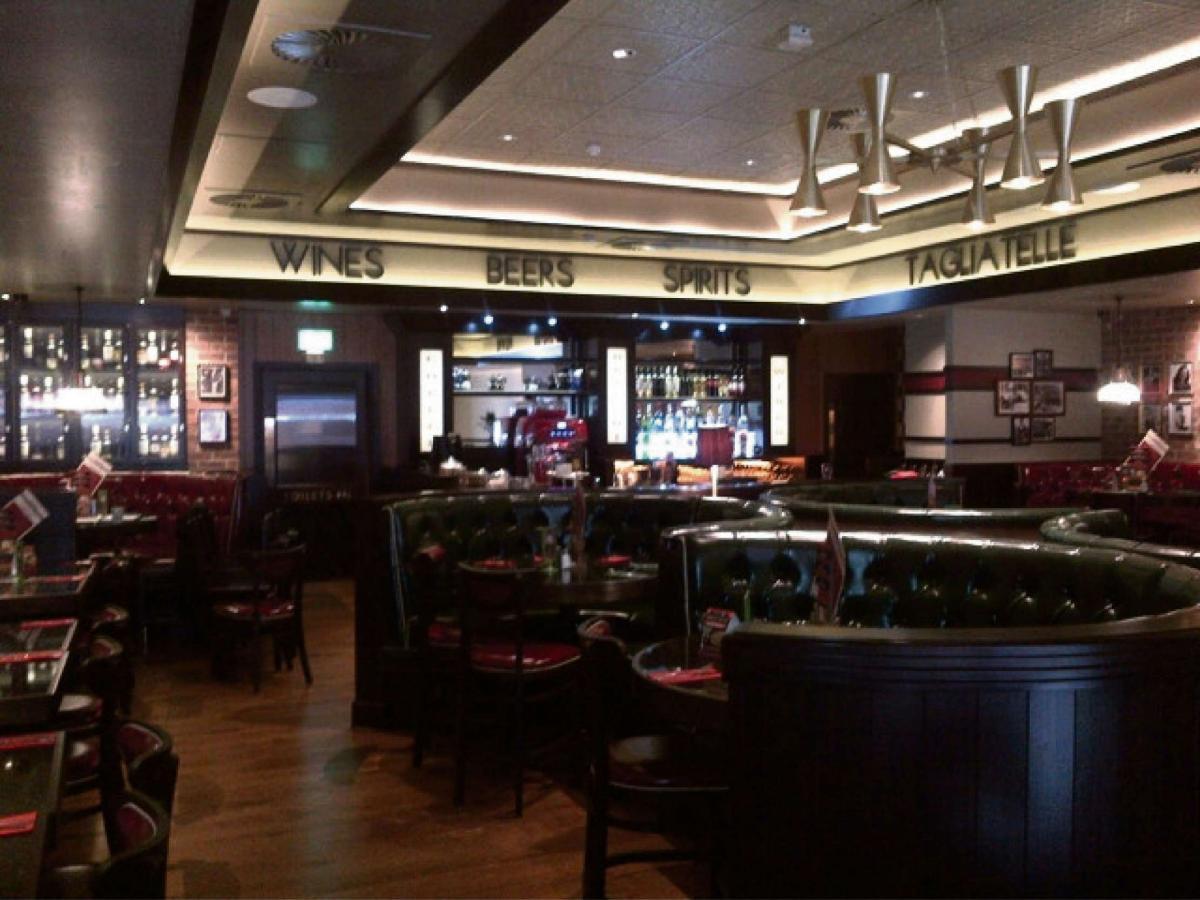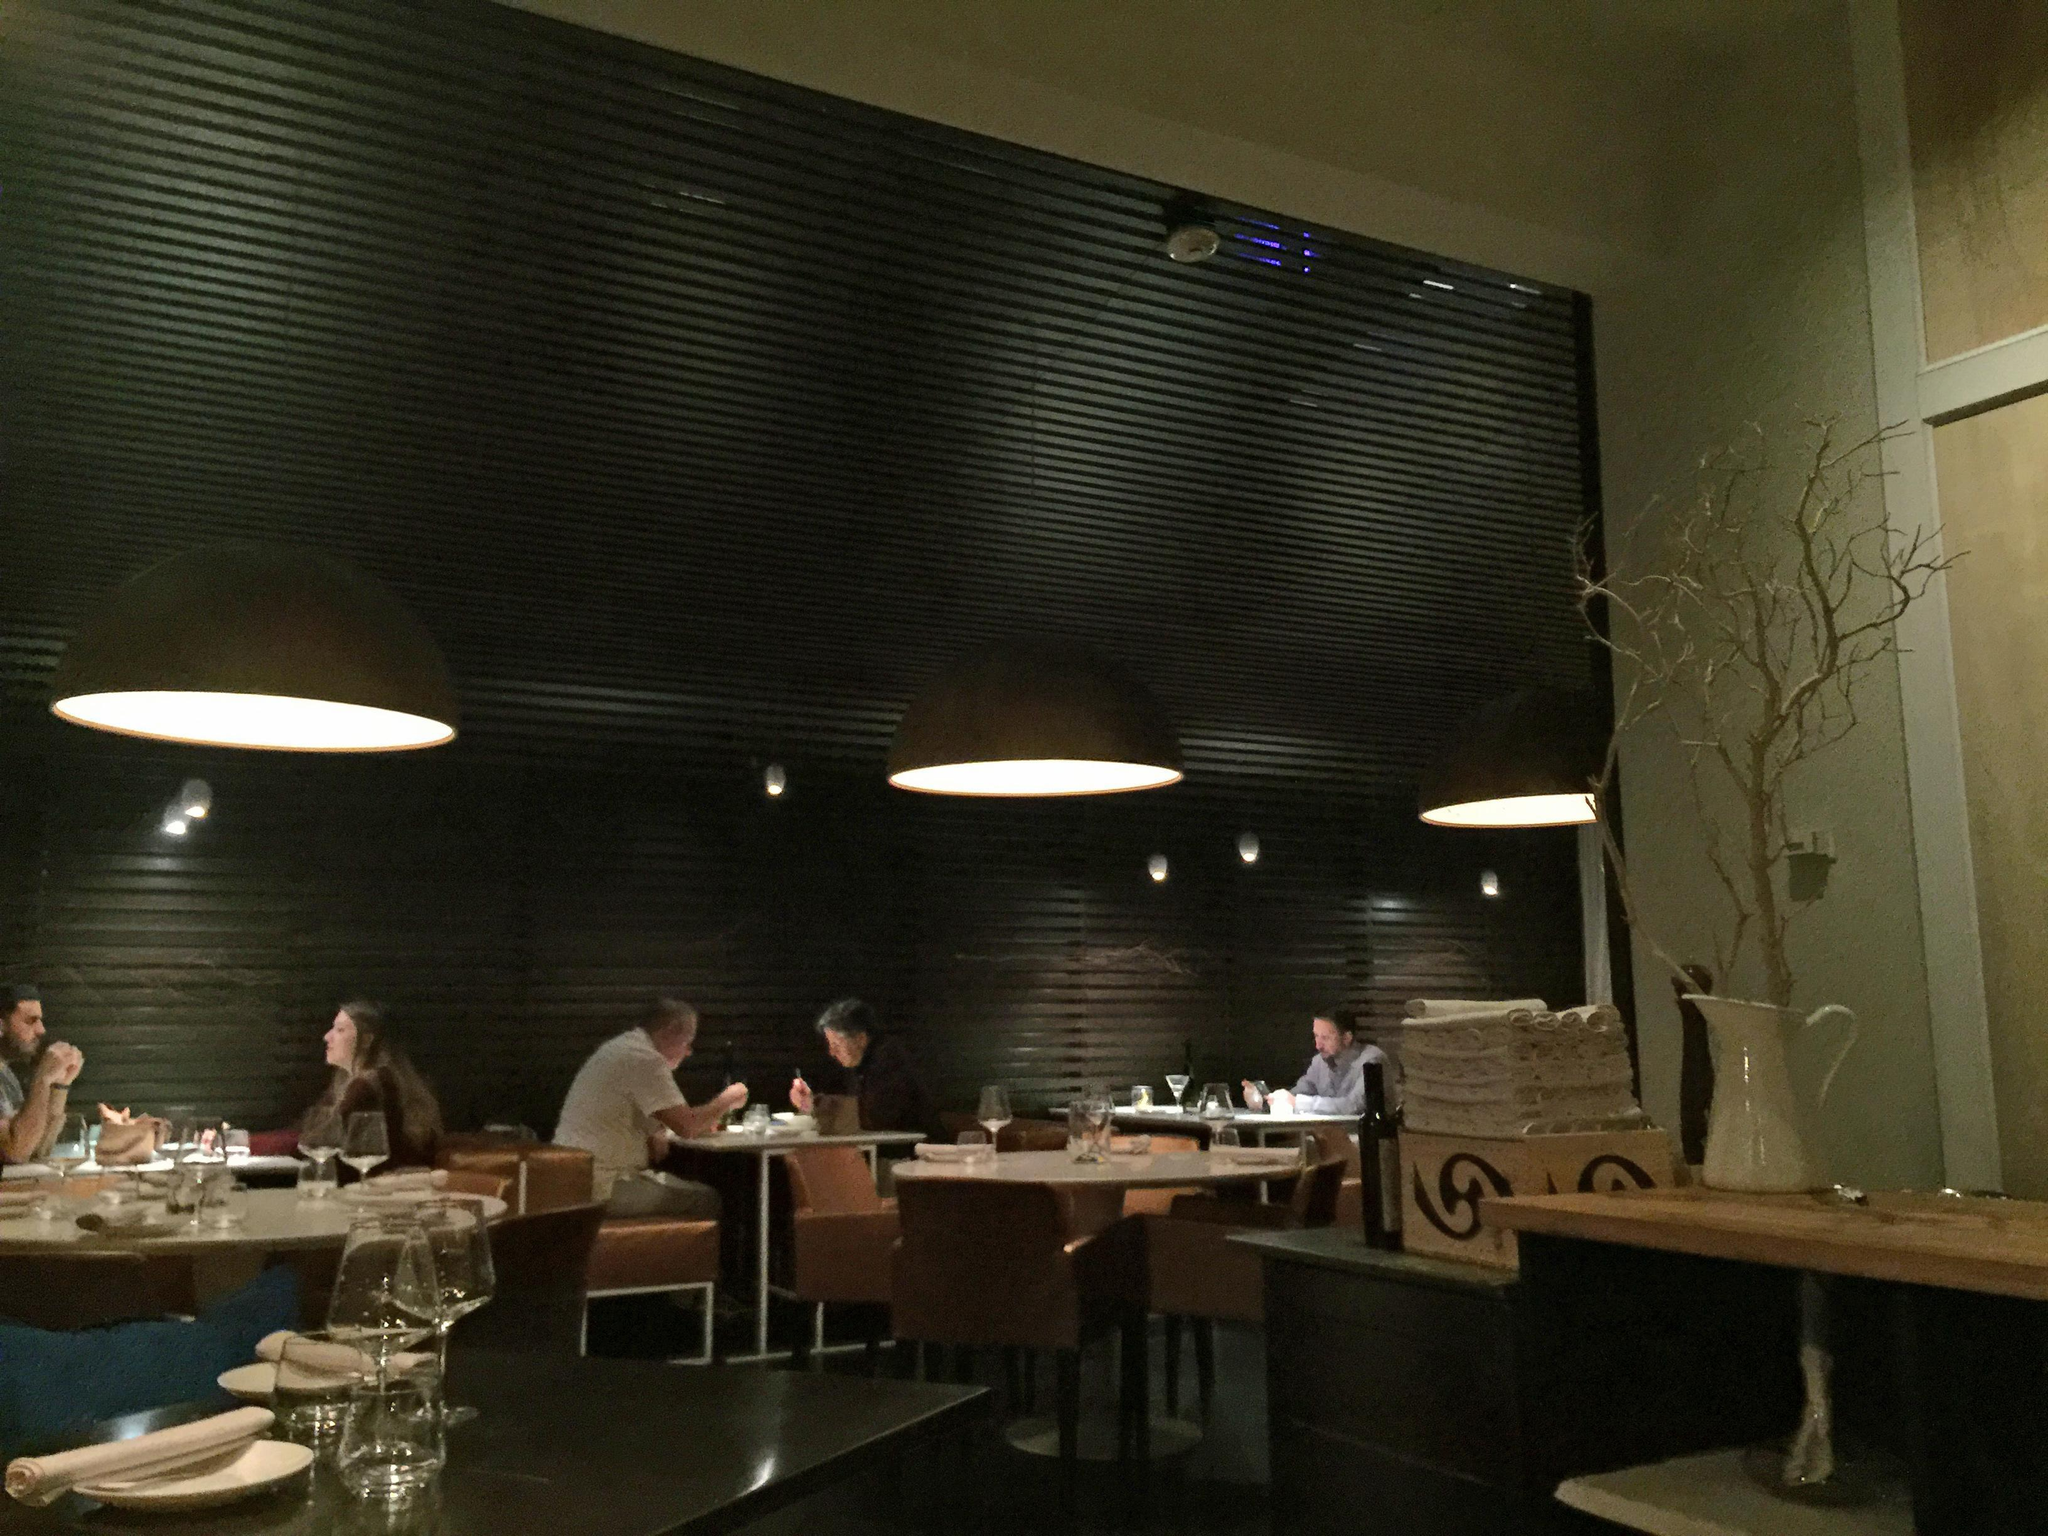The first image is the image on the left, the second image is the image on the right. Given the left and right images, does the statement "You can see barstools in one of the images." hold true? Answer yes or no. No. The first image is the image on the left, the second image is the image on the right. Considering the images on both sides, is "The right image shows a line of black benches with tufted backs in front of a low divider wall with a curtain behind it, and under lit hanging lights." valid? Answer yes or no. No. 